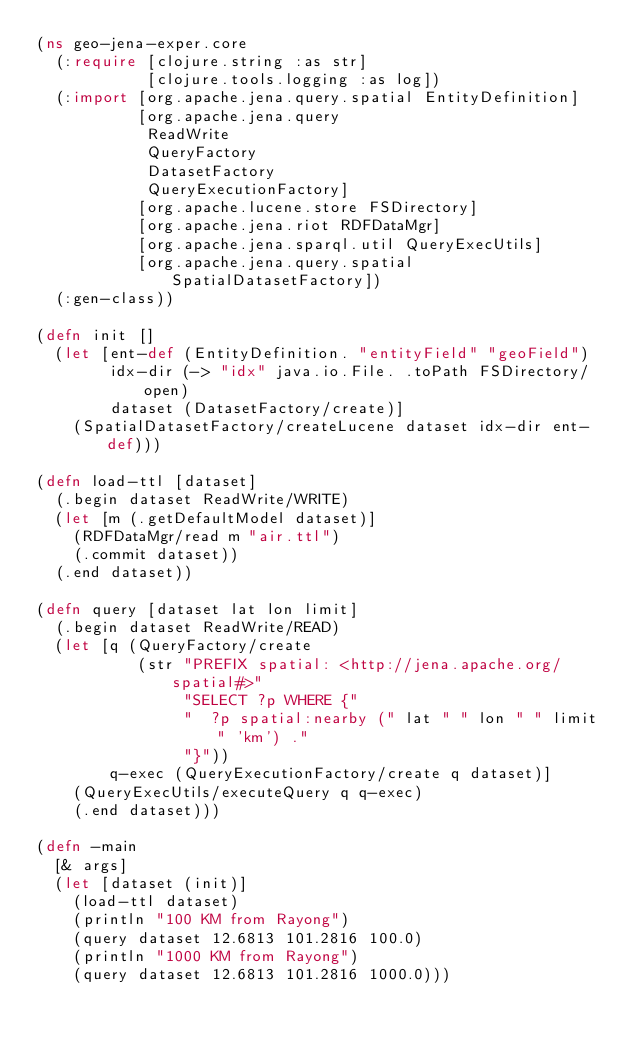<code> <loc_0><loc_0><loc_500><loc_500><_Clojure_>(ns geo-jena-exper.core
  (:require [clojure.string :as str]
            [clojure.tools.logging :as log])
  (:import [org.apache.jena.query.spatial EntityDefinition]
           [org.apache.jena.query
            ReadWrite
            QueryFactory
            DatasetFactory
            QueryExecutionFactory]
           [org.apache.lucene.store FSDirectory]
           [org.apache.jena.riot RDFDataMgr]
           [org.apache.jena.sparql.util QueryExecUtils]
           [org.apache.jena.query.spatial SpatialDatasetFactory])
  (:gen-class))

(defn init []
  (let [ent-def (EntityDefinition. "entityField" "geoField")
        idx-dir (-> "idx" java.io.File. .toPath FSDirectory/open)
        dataset (DatasetFactory/create)]
    (SpatialDatasetFactory/createLucene dataset idx-dir ent-def)))

(defn load-ttl [dataset]
  (.begin dataset ReadWrite/WRITE)
  (let [m (.getDefaultModel dataset)]
    (RDFDataMgr/read m "air.ttl")
    (.commit dataset))
  (.end dataset))

(defn query [dataset lat lon limit]
  (.begin dataset ReadWrite/READ)
  (let [q (QueryFactory/create
           (str "PREFIX spatial: <http://jena.apache.org/spatial#>"
                "SELECT ?p WHERE {"
                "  ?p spatial:nearby (" lat " " lon " " limit " 'km') ."
                "}"))
        q-exec (QueryExecutionFactory/create q dataset)]
    (QueryExecUtils/executeQuery q q-exec)
    (.end dataset)))

(defn -main
  [& args]
  (let [dataset (init)]
    (load-ttl dataset)
    (println "100 KM from Rayong")
    (query dataset 12.6813 101.2816 100.0)
    (println "1000 KM from Rayong")
    (query dataset 12.6813 101.2816 1000.0)))
</code> 